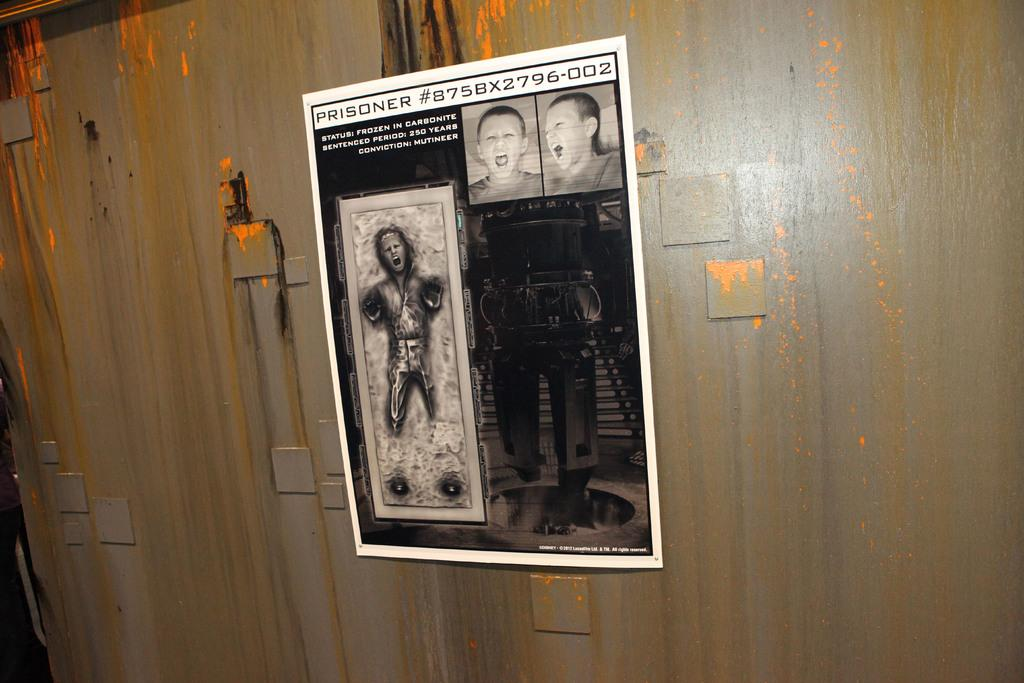<image>
Offer a succinct explanation of the picture presented. A poster about a prisoner hangs on a wall. 